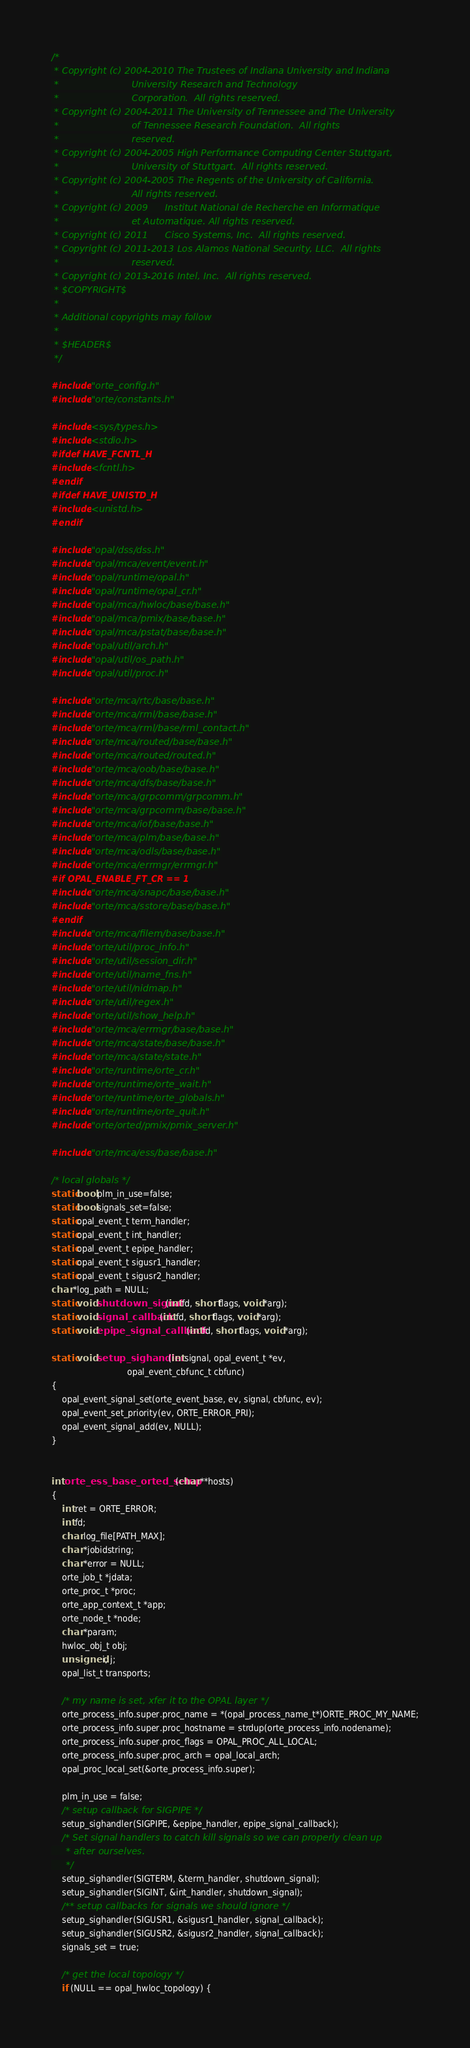Convert code to text. <code><loc_0><loc_0><loc_500><loc_500><_C_>/*
 * Copyright (c) 2004-2010 The Trustees of Indiana University and Indiana
 *                         University Research and Technology
 *                         Corporation.  All rights reserved.
 * Copyright (c) 2004-2011 The University of Tennessee and The University
 *                         of Tennessee Research Foundation.  All rights
 *                         reserved.
 * Copyright (c) 2004-2005 High Performance Computing Center Stuttgart,
 *                         University of Stuttgart.  All rights reserved.
 * Copyright (c) 2004-2005 The Regents of the University of California.
 *                         All rights reserved.
 * Copyright (c) 2009      Institut National de Recherche en Informatique
 *                         et Automatique. All rights reserved.
 * Copyright (c) 2011      Cisco Systems, Inc.  All rights reserved.
 * Copyright (c) 2011-2013 Los Alamos National Security, LLC.  All rights
 *                         reserved.
 * Copyright (c) 2013-2016 Intel, Inc.  All rights reserved.
 * $COPYRIGHT$
 *
 * Additional copyrights may follow
 *
 * $HEADER$
 */

#include "orte_config.h"
#include "orte/constants.h"

#include <sys/types.h>
#include <stdio.h>
#ifdef HAVE_FCNTL_H
#include <fcntl.h>
#endif
#ifdef HAVE_UNISTD_H
#include <unistd.h>
#endif

#include "opal/dss/dss.h"
#include "opal/mca/event/event.h"
#include "opal/runtime/opal.h"
#include "opal/runtime/opal_cr.h"
#include "opal/mca/hwloc/base/base.h"
#include "opal/mca/pmix/base/base.h"
#include "opal/mca/pstat/base/base.h"
#include "opal/util/arch.h"
#include "opal/util/os_path.h"
#include "opal/util/proc.h"

#include "orte/mca/rtc/base/base.h"
#include "orte/mca/rml/base/base.h"
#include "orte/mca/rml/base/rml_contact.h"
#include "orte/mca/routed/base/base.h"
#include "orte/mca/routed/routed.h"
#include "orte/mca/oob/base/base.h"
#include "orte/mca/dfs/base/base.h"
#include "orte/mca/grpcomm/grpcomm.h"
#include "orte/mca/grpcomm/base/base.h"
#include "orte/mca/iof/base/base.h"
#include "orte/mca/plm/base/base.h"
#include "orte/mca/odls/base/base.h"
#include "orte/mca/errmgr/errmgr.h"
#if OPAL_ENABLE_FT_CR == 1
#include "orte/mca/snapc/base/base.h"
#include "orte/mca/sstore/base/base.h"
#endif
#include "orte/mca/filem/base/base.h"
#include "orte/util/proc_info.h"
#include "orte/util/session_dir.h"
#include "orte/util/name_fns.h"
#include "orte/util/nidmap.h"
#include "orte/util/regex.h"
#include "orte/util/show_help.h"
#include "orte/mca/errmgr/base/base.h"
#include "orte/mca/state/base/base.h"
#include "orte/mca/state/state.h"
#include "orte/runtime/orte_cr.h"
#include "orte/runtime/orte_wait.h"
#include "orte/runtime/orte_globals.h"
#include "orte/runtime/orte_quit.h"
#include "orte/orted/pmix/pmix_server.h"

#include "orte/mca/ess/base/base.h"

/* local globals */
static bool plm_in_use=false;
static bool signals_set=false;
static opal_event_t term_handler;
static opal_event_t int_handler;
static opal_event_t epipe_handler;
static opal_event_t sigusr1_handler;
static opal_event_t sigusr2_handler;
char *log_path = NULL;
static void shutdown_signal(int fd, short flags, void *arg);
static void signal_callback(int fd, short flags, void *arg);
static void epipe_signal_callback(int fd, short flags, void *arg);

static void setup_sighandler(int signal, opal_event_t *ev,
                             opal_event_cbfunc_t cbfunc)
{
    opal_event_signal_set(orte_event_base, ev, signal, cbfunc, ev);
    opal_event_set_priority(ev, ORTE_ERROR_PRI);
    opal_event_signal_add(ev, NULL);
}


int orte_ess_base_orted_setup(char **hosts)
{
    int ret = ORTE_ERROR;
    int fd;
    char log_file[PATH_MAX];
    char *jobidstring;
    char *error = NULL;
    orte_job_t *jdata;
    orte_proc_t *proc;
    orte_app_context_t *app;
    orte_node_t *node;
    char *param;
    hwloc_obj_t obj;
    unsigned i, j;
    opal_list_t transports;

    /* my name is set, xfer it to the OPAL layer */
    orte_process_info.super.proc_name = *(opal_process_name_t*)ORTE_PROC_MY_NAME;
    orte_process_info.super.proc_hostname = strdup(orte_process_info.nodename);
    orte_process_info.super.proc_flags = OPAL_PROC_ALL_LOCAL;
    orte_process_info.super.proc_arch = opal_local_arch;
    opal_proc_local_set(&orte_process_info.super);

    plm_in_use = false;
    /* setup callback for SIGPIPE */
    setup_sighandler(SIGPIPE, &epipe_handler, epipe_signal_callback);
    /* Set signal handlers to catch kill signals so we can properly clean up
     * after ourselves.
     */
    setup_sighandler(SIGTERM, &term_handler, shutdown_signal);
    setup_sighandler(SIGINT, &int_handler, shutdown_signal);
    /** setup callbacks for signals we should ignore */
    setup_sighandler(SIGUSR1, &sigusr1_handler, signal_callback);
    setup_sighandler(SIGUSR2, &sigusr2_handler, signal_callback);
    signals_set = true;

    /* get the local topology */
    if (NULL == opal_hwloc_topology) {</code> 